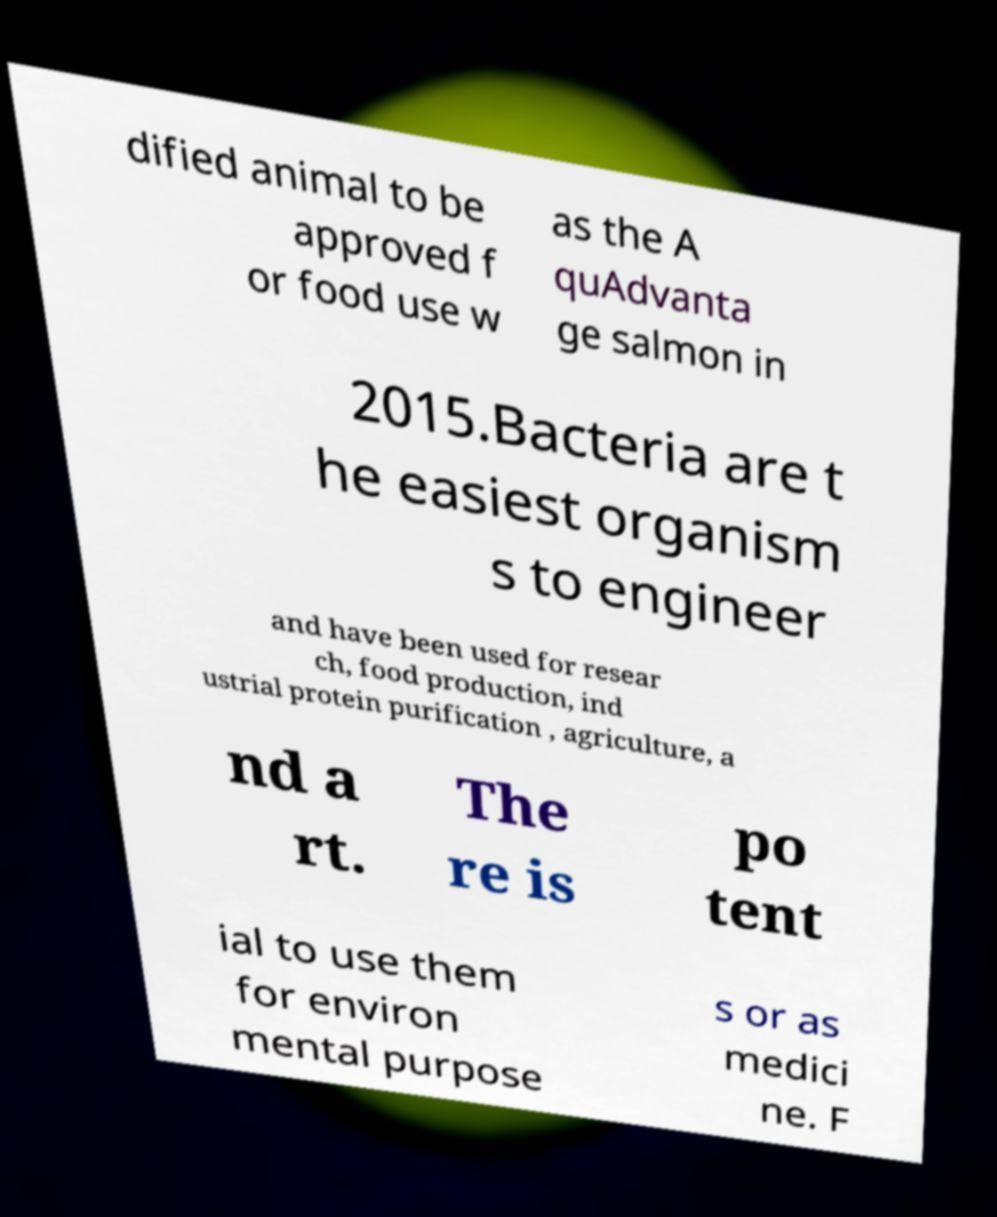I need the written content from this picture converted into text. Can you do that? dified animal to be approved f or food use w as the A quAdvanta ge salmon in 2015.Bacteria are t he easiest organism s to engineer and have been used for resear ch, food production, ind ustrial protein purification , agriculture, a nd a rt. The re is po tent ial to use them for environ mental purpose s or as medici ne. F 